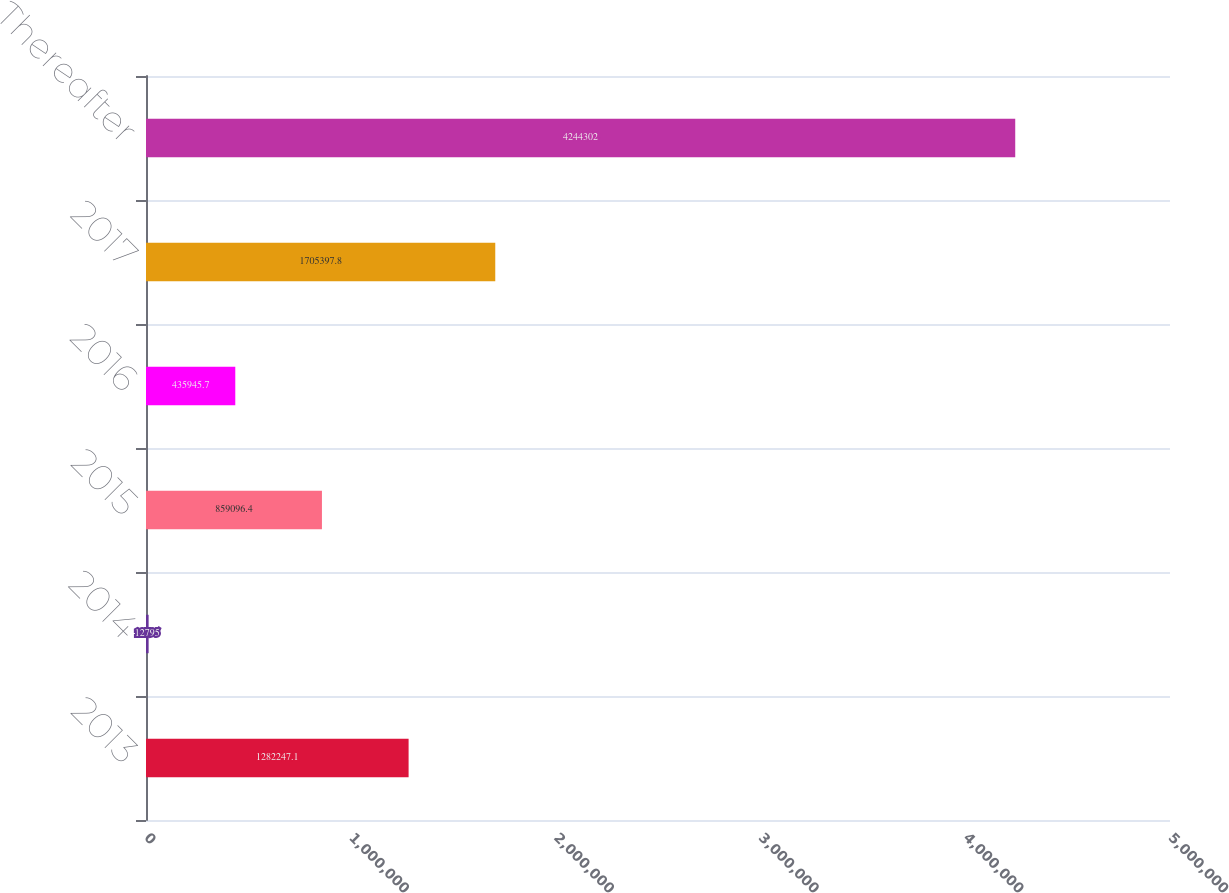Convert chart. <chart><loc_0><loc_0><loc_500><loc_500><bar_chart><fcel>2013<fcel>2014<fcel>2015<fcel>2016<fcel>2017<fcel>Thereafter<nl><fcel>1.28225e+06<fcel>12795<fcel>859096<fcel>435946<fcel>1.7054e+06<fcel>4.2443e+06<nl></chart> 